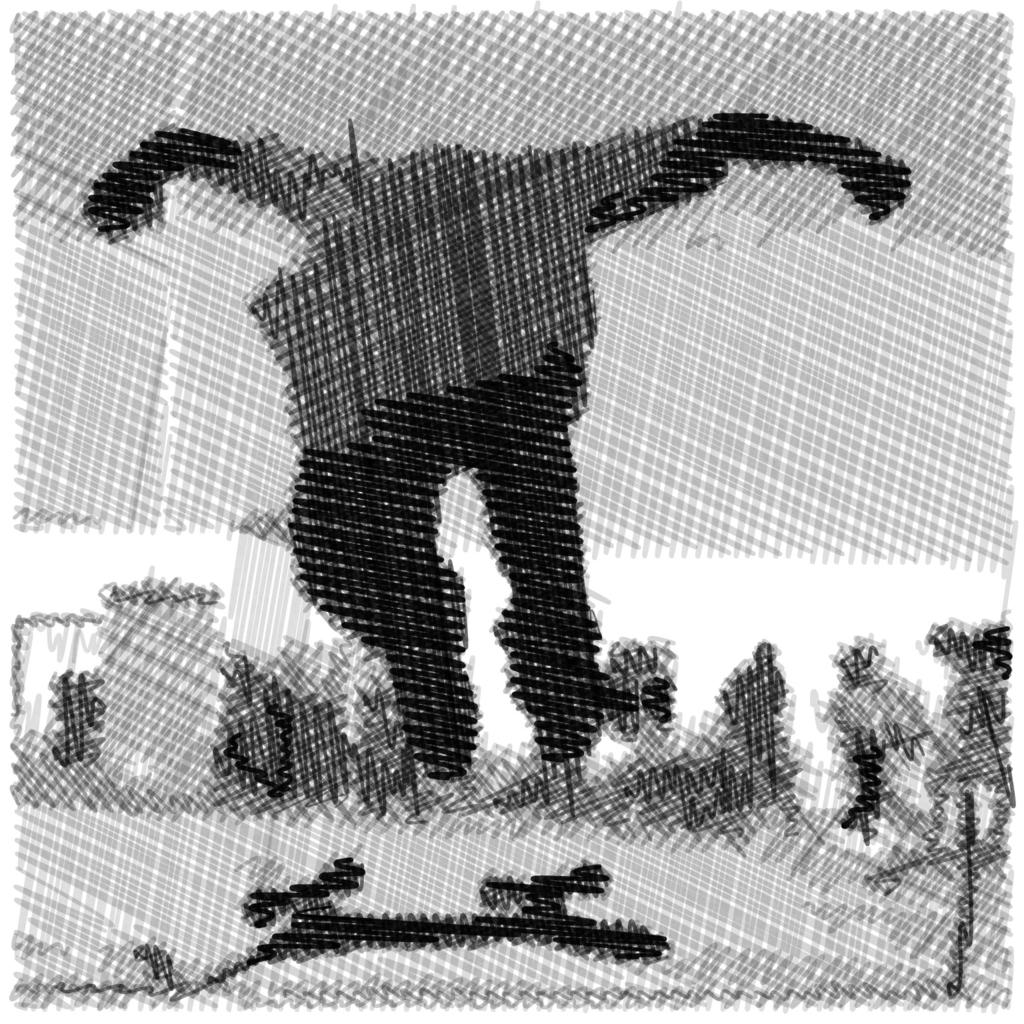What type of image is being described? The image is animated. What can be seen on the characters in the image? There are costumes in the image. What type of natural elements are present in the image? There are plants in the image. What type of street is visible in the image? There is no street present in the image; it is an animated scene with costumes and plants. How many bombs can be seen in the image? There are no bombs present in the image. 